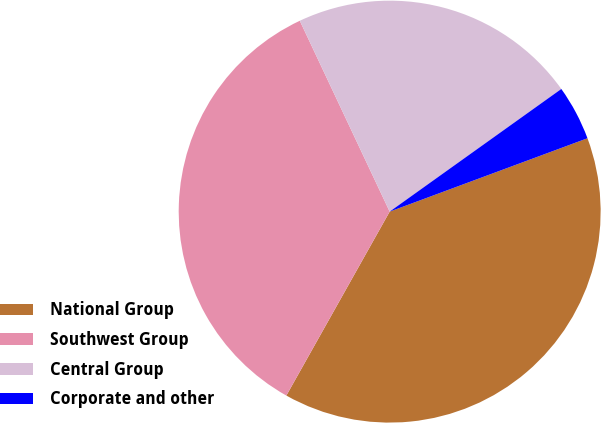Convert chart to OTSL. <chart><loc_0><loc_0><loc_500><loc_500><pie_chart><fcel>National Group<fcel>Southwest Group<fcel>Central Group<fcel>Corporate and other<nl><fcel>38.8%<fcel>34.85%<fcel>22.13%<fcel>4.22%<nl></chart> 